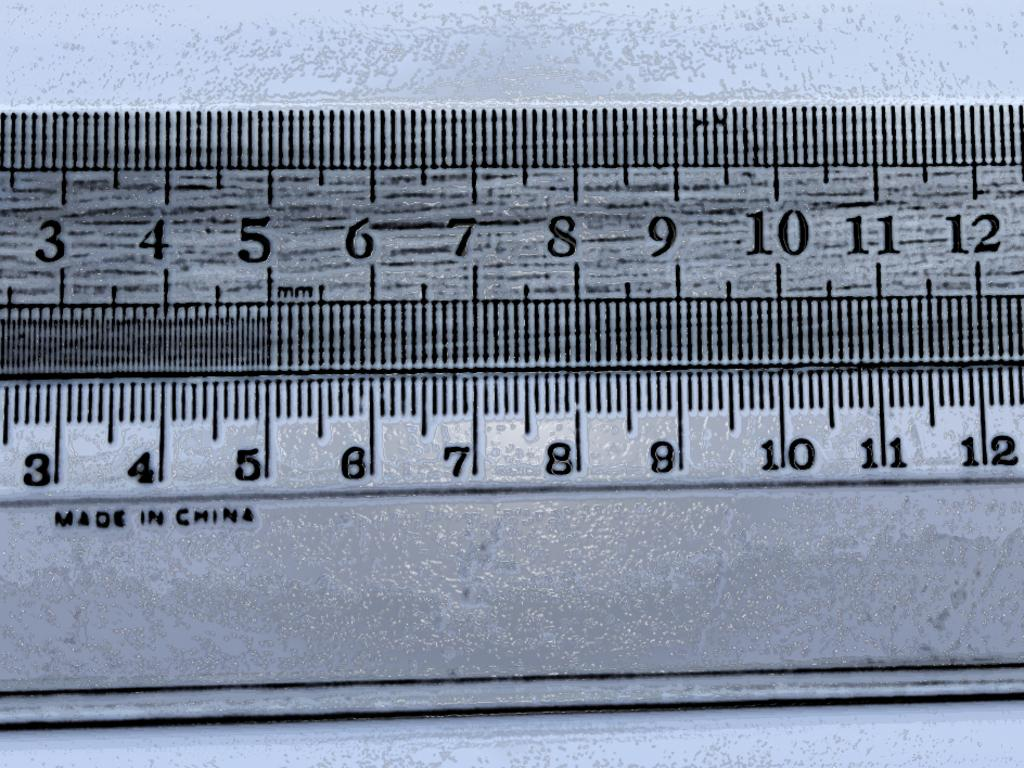<image>
Offer a succinct explanation of the picture presented. the measuring tool is labeled that it was made in china 